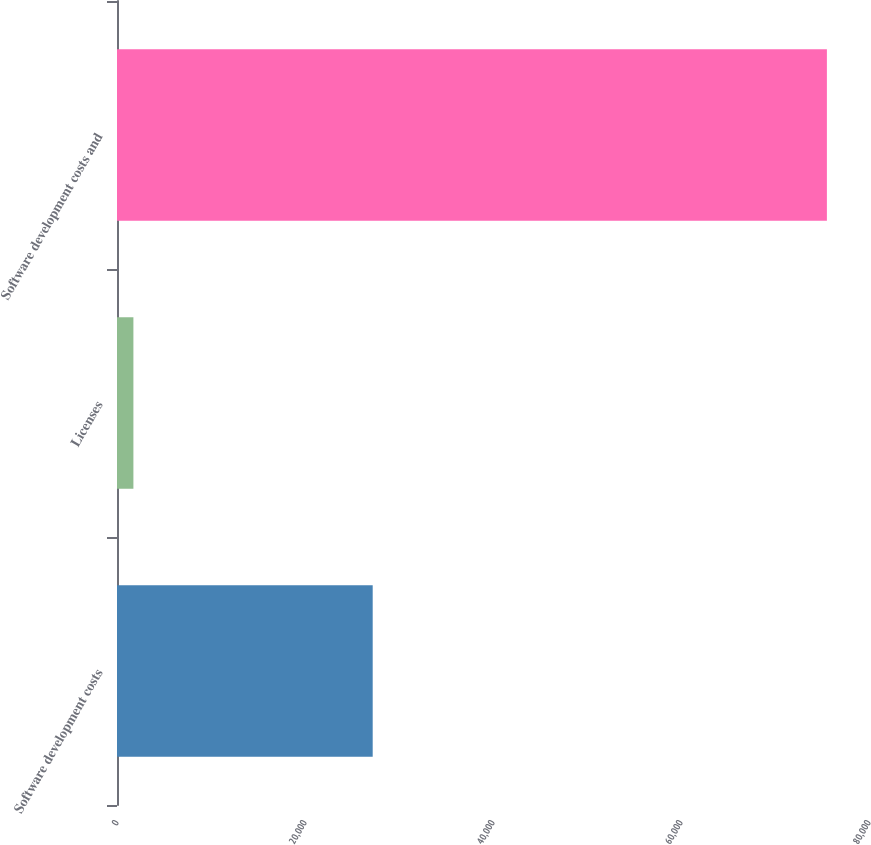Convert chart. <chart><loc_0><loc_0><loc_500><loc_500><bar_chart><fcel>Software development costs<fcel>Licenses<fcel>Software development costs and<nl><fcel>27202<fcel>1745<fcel>75521<nl></chart> 